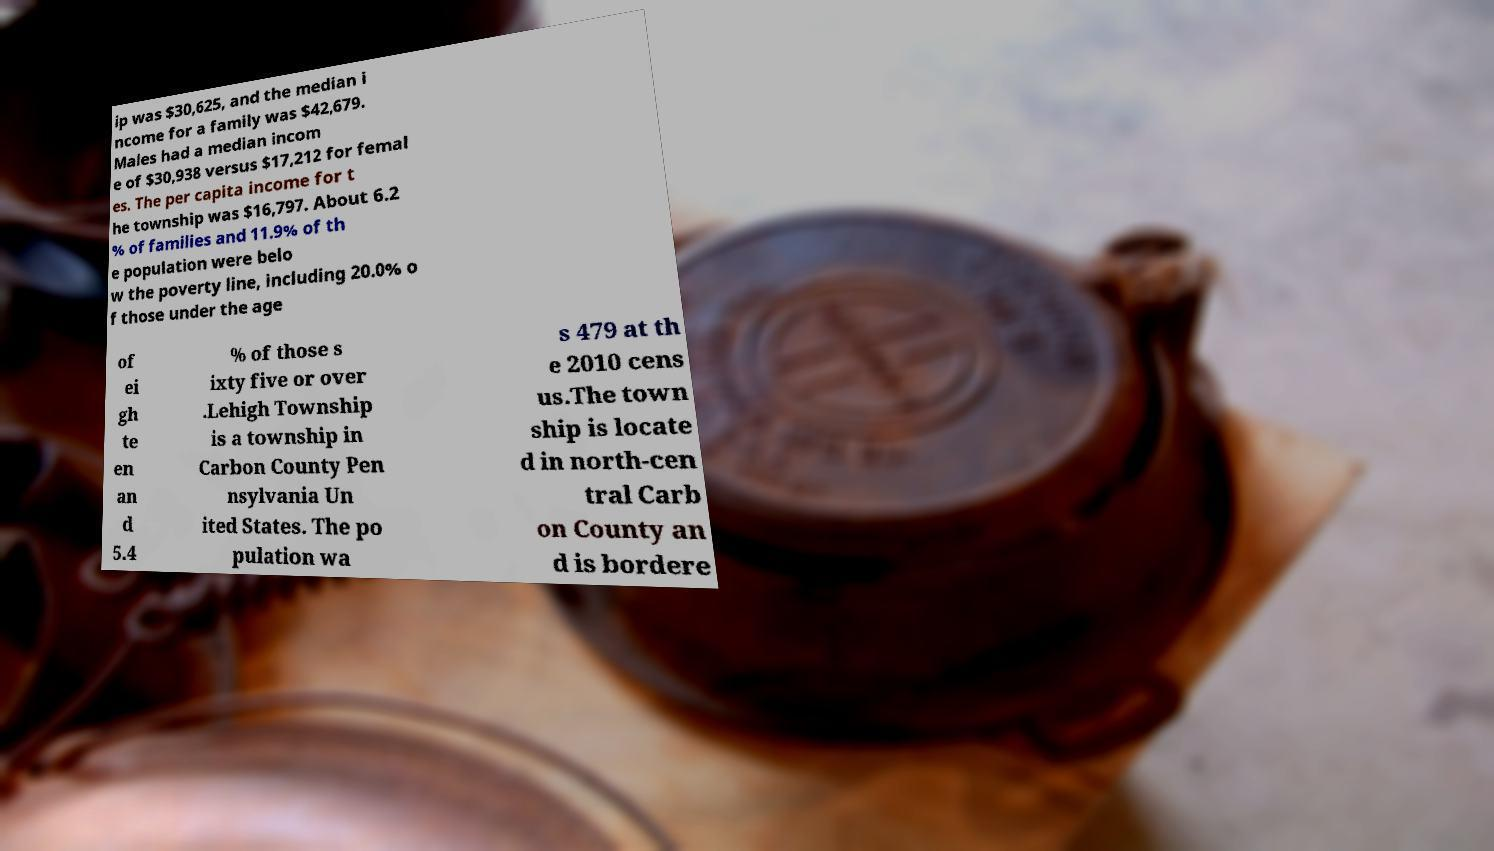What messages or text are displayed in this image? I need them in a readable, typed format. ip was $30,625, and the median i ncome for a family was $42,679. Males had a median incom e of $30,938 versus $17,212 for femal es. The per capita income for t he township was $16,797. About 6.2 % of families and 11.9% of th e population were belo w the poverty line, including 20.0% o f those under the age of ei gh te en an d 5.4 % of those s ixty five or over .Lehigh Township is a township in Carbon County Pen nsylvania Un ited States. The po pulation wa s 479 at th e 2010 cens us.The town ship is locate d in north-cen tral Carb on County an d is bordere 